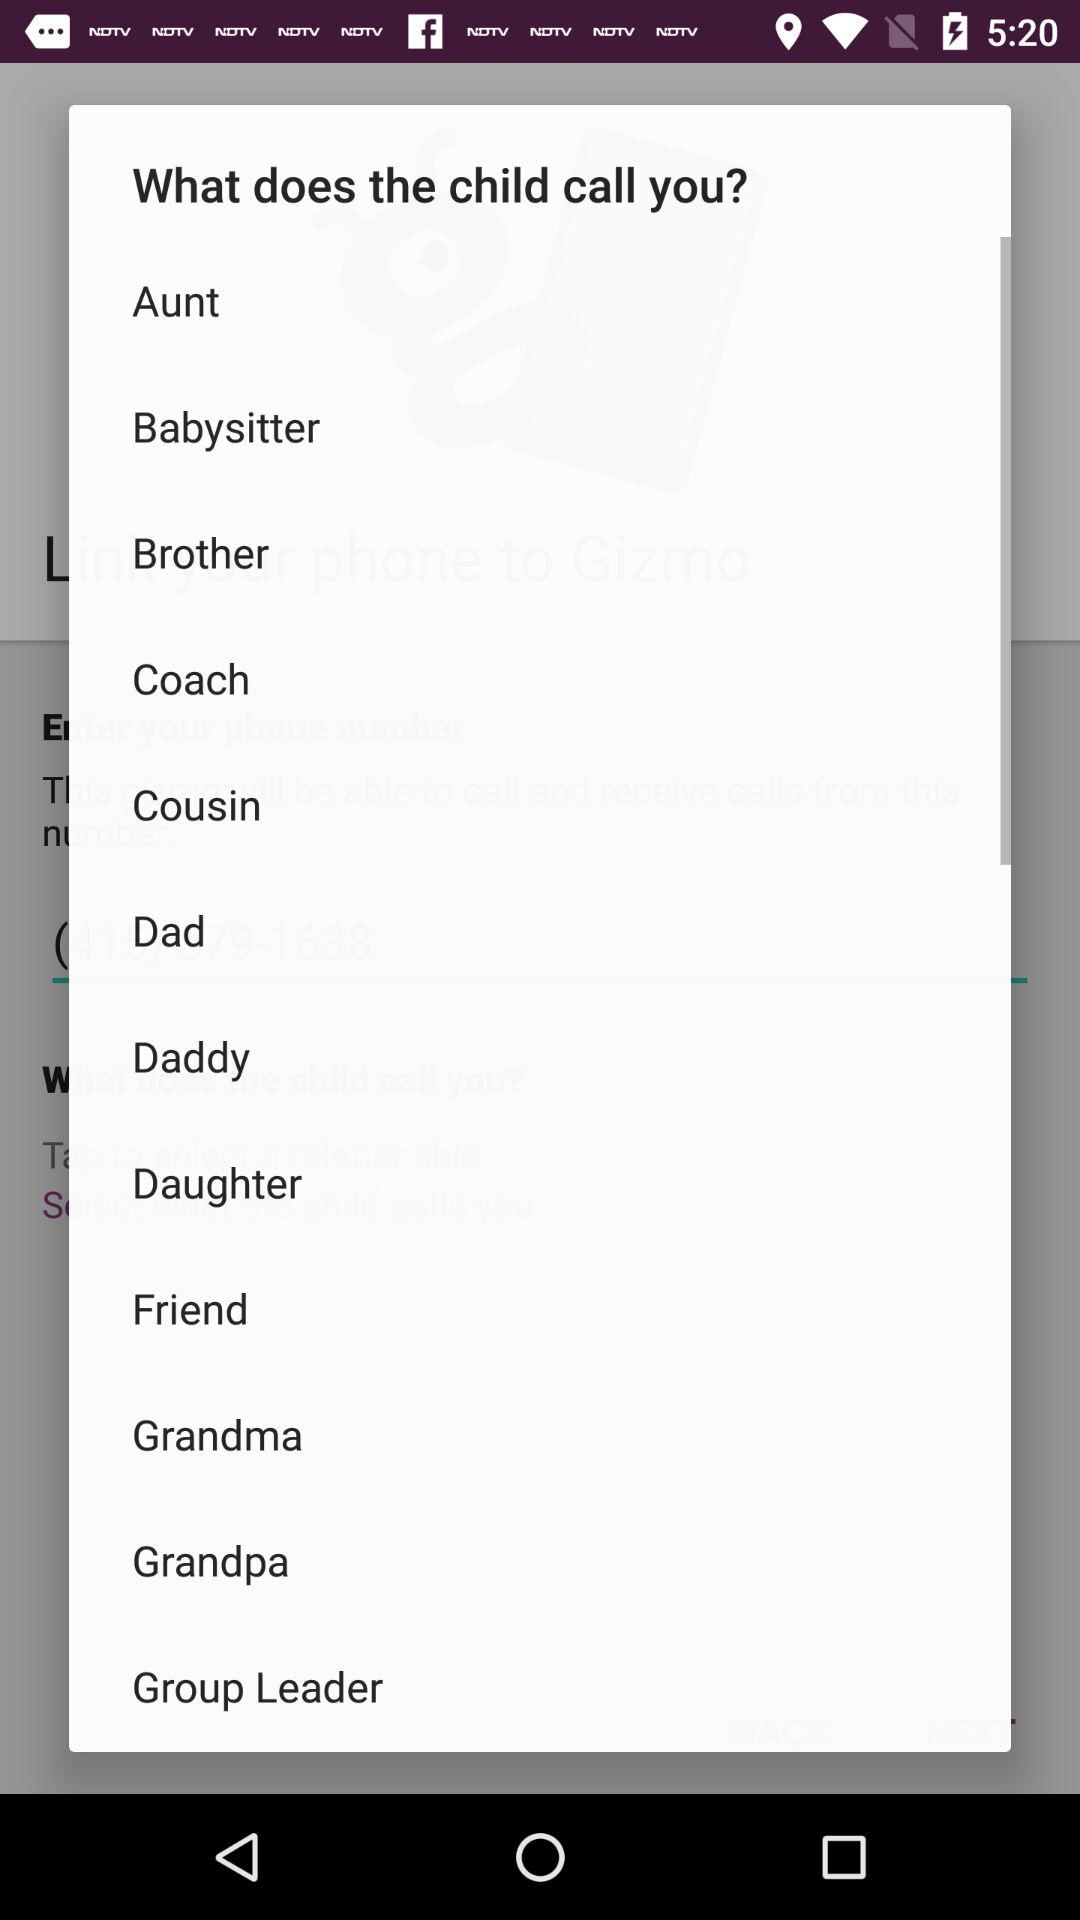How many titles are there for the child to choose from?
Answer the question using a single word or phrase. 12 